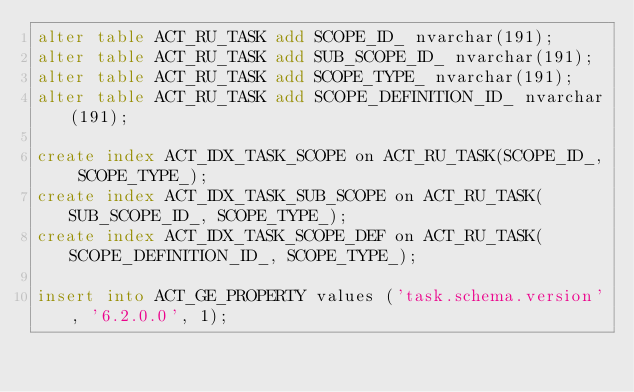<code> <loc_0><loc_0><loc_500><loc_500><_SQL_>alter table ACT_RU_TASK add SCOPE_ID_ nvarchar(191);
alter table ACT_RU_TASK add SUB_SCOPE_ID_ nvarchar(191);
alter table ACT_RU_TASK add SCOPE_TYPE_ nvarchar(191);
alter table ACT_RU_TASK add SCOPE_DEFINITION_ID_ nvarchar(191);

create index ACT_IDX_TASK_SCOPE on ACT_RU_TASK(SCOPE_ID_, SCOPE_TYPE_);
create index ACT_IDX_TASK_SUB_SCOPE on ACT_RU_TASK(SUB_SCOPE_ID_, SCOPE_TYPE_);
create index ACT_IDX_TASK_SCOPE_DEF on ACT_RU_TASK(SCOPE_DEFINITION_ID_, SCOPE_TYPE_);

insert into ACT_GE_PROPERTY values ('task.schema.version', '6.2.0.0', 1);</code> 